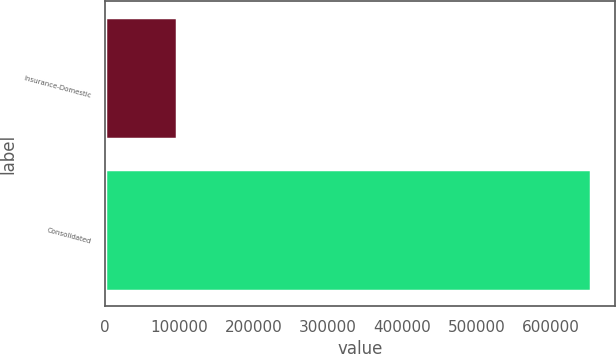Convert chart to OTSL. <chart><loc_0><loc_0><loc_500><loc_500><bar_chart><fcel>Insurance-Domestic<fcel>Consolidated<nl><fcel>96487<fcel>653203<nl></chart> 